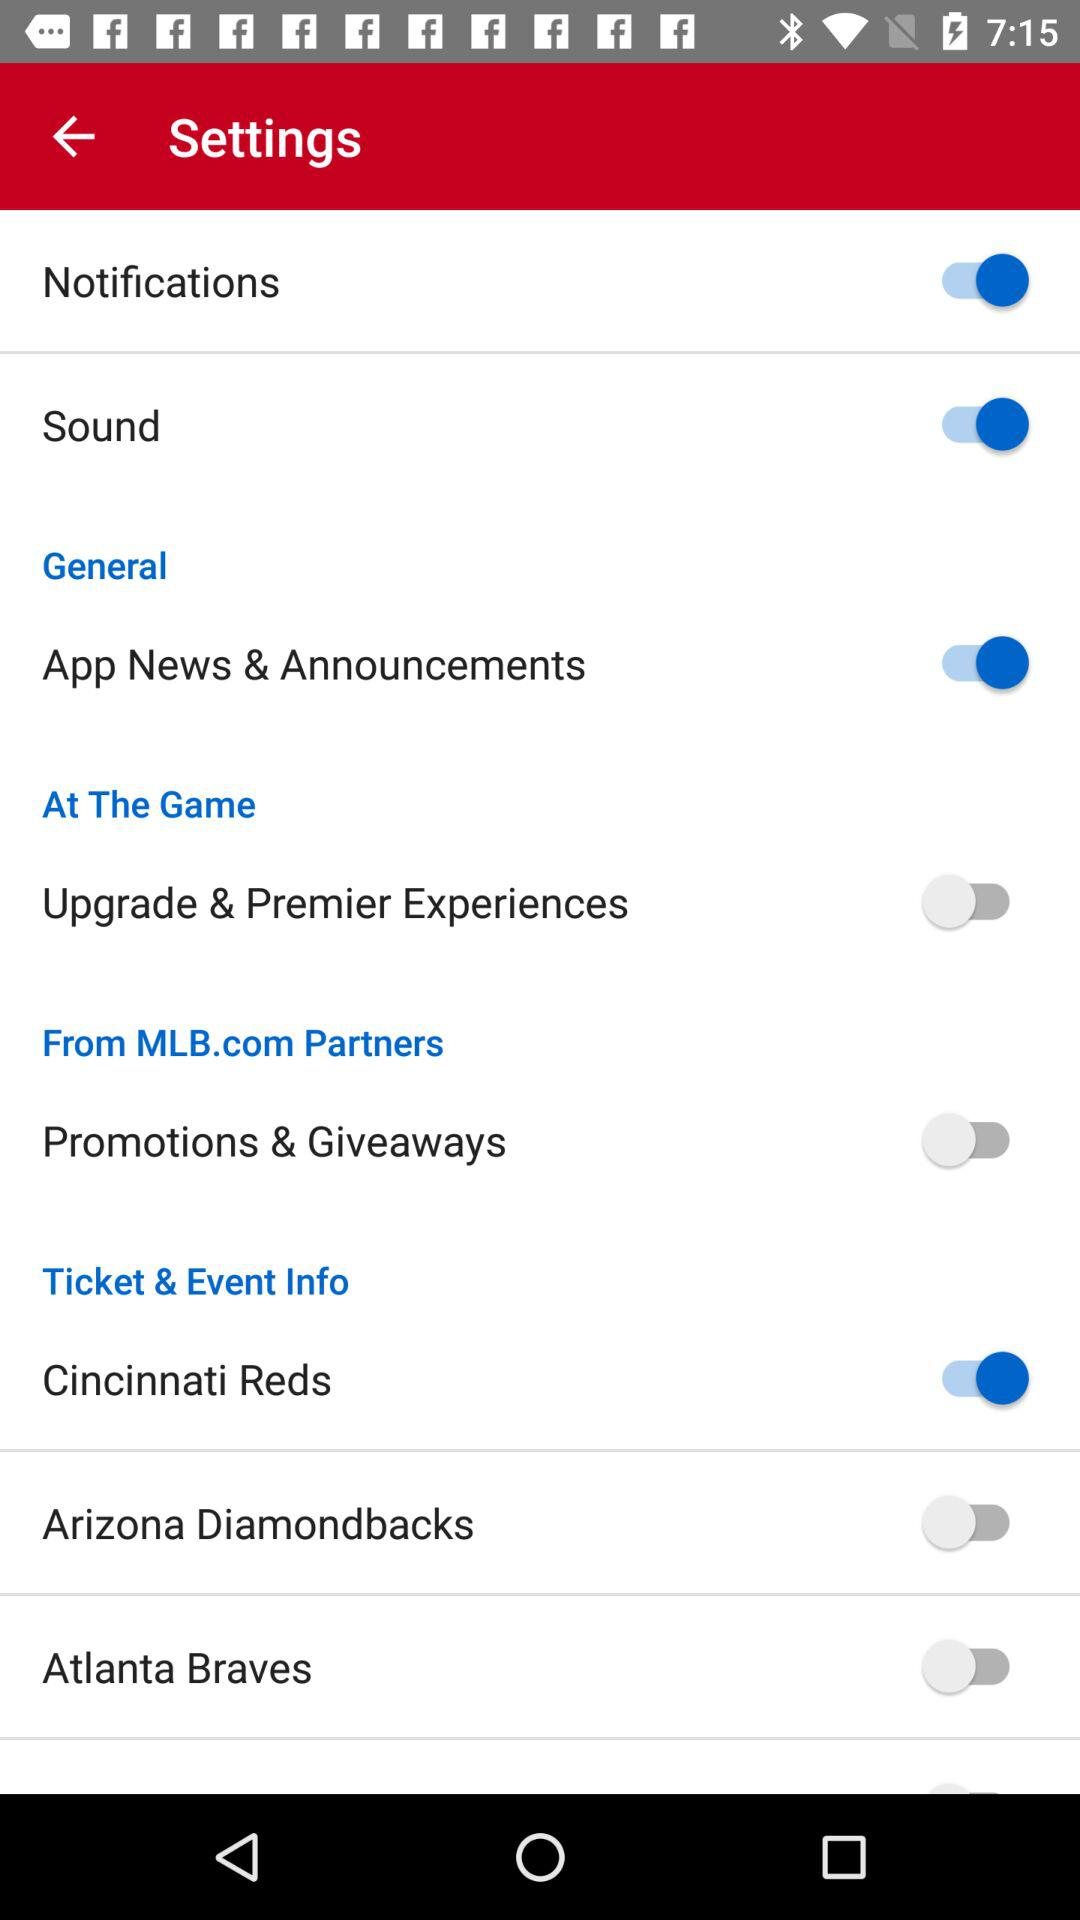Is "General" checked or unchecked?
When the provided information is insufficient, respond with <no answer>. <no answer> 